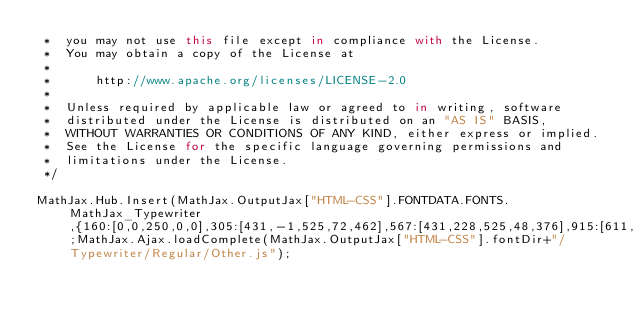Convert code to text. <code><loc_0><loc_0><loc_500><loc_500><_JavaScript_> *  you may not use this file except in compliance with the License.
 *  You may obtain a copy of the License at
 *
 *      http://www.apache.org/licenses/LICENSE-2.0
 *
 *  Unless required by applicable law or agreed to in writing, software
 *  distributed under the License is distributed on an "AS IS" BASIS,
 *  WITHOUT WARRANTIES OR CONDITIONS OF ANY KIND, either express or implied.
 *  See the License for the specific language governing permissions and
 *  limitations under the License.
 */

MathJax.Hub.Insert(MathJax.OutputJax["HTML-CSS"].FONTDATA.FONTS.MathJax_Typewriter,{160:[0,0,250,0,0],305:[431,-1,525,72,462],567:[431,228,525,48,376],915:[611,0,525,25,488],916:[623,0,525,35,489],920:[621,10,525,56,468],923:[623,-1,525,30,495],926:[611,-1,525,33,491],928:[611,-1,525,16,508],931:[611,-1,525,40,484],933:[622,-1,525,38,486],934:[611,-1,525,41,483],936:[611,-1,525,37,487],937:[622,-1,525,32,492],2018:[611,-287,525,175,349],2019:[681,-357,525,176,350],8242:[623,-334,525,211,313]});MathJax.Ajax.loadComplete(MathJax.OutputJax["HTML-CSS"].fontDir+"/Typewriter/Regular/Other.js");
</code> 